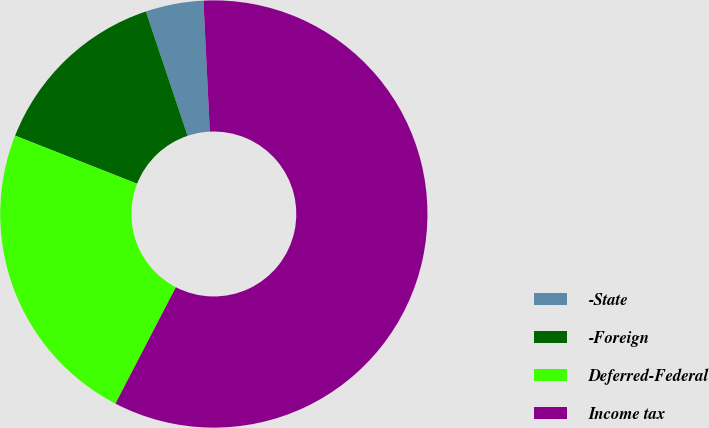<chart> <loc_0><loc_0><loc_500><loc_500><pie_chart><fcel>-State<fcel>-Foreign<fcel>Deferred-Federal<fcel>Income tax<nl><fcel>4.38%<fcel>13.87%<fcel>23.36%<fcel>58.39%<nl></chart> 